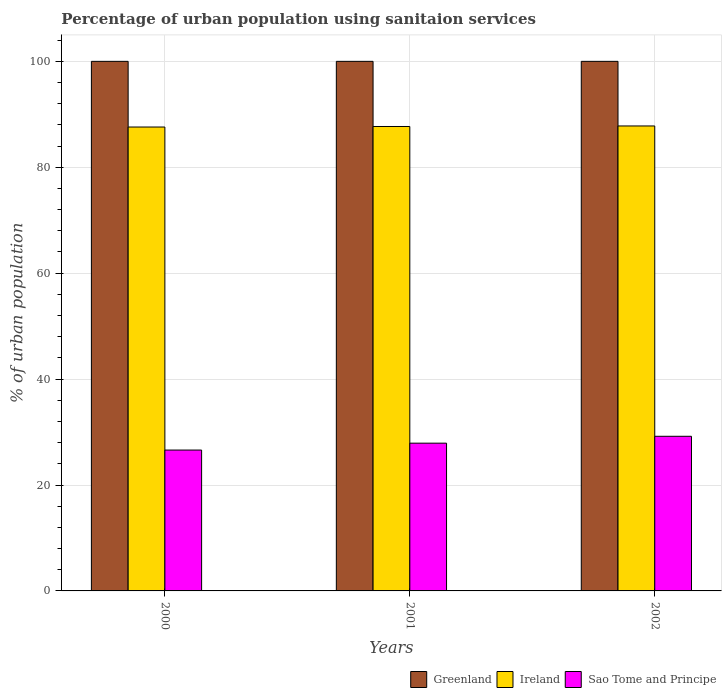How many different coloured bars are there?
Your answer should be very brief. 3. Are the number of bars per tick equal to the number of legend labels?
Your answer should be very brief. Yes. How many bars are there on the 1st tick from the right?
Offer a terse response. 3. What is the label of the 1st group of bars from the left?
Offer a terse response. 2000. In how many cases, is the number of bars for a given year not equal to the number of legend labels?
Provide a succinct answer. 0. What is the percentage of urban population using sanitaion services in Greenland in 2002?
Your answer should be compact. 100. Across all years, what is the maximum percentage of urban population using sanitaion services in Greenland?
Your answer should be very brief. 100. Across all years, what is the minimum percentage of urban population using sanitaion services in Greenland?
Offer a very short reply. 100. In which year was the percentage of urban population using sanitaion services in Greenland minimum?
Ensure brevity in your answer.  2000. What is the total percentage of urban population using sanitaion services in Sao Tome and Principe in the graph?
Provide a short and direct response. 83.7. What is the difference between the percentage of urban population using sanitaion services in Ireland in 2000 and that in 2002?
Your response must be concise. -0.2. What is the difference between the percentage of urban population using sanitaion services in Ireland in 2000 and the percentage of urban population using sanitaion services in Sao Tome and Principe in 2002?
Give a very brief answer. 58.4. In the year 2000, what is the difference between the percentage of urban population using sanitaion services in Greenland and percentage of urban population using sanitaion services in Sao Tome and Principe?
Ensure brevity in your answer.  73.4. In how many years, is the percentage of urban population using sanitaion services in Sao Tome and Principe greater than 12 %?
Give a very brief answer. 3. What is the ratio of the percentage of urban population using sanitaion services in Ireland in 2000 to that in 2001?
Keep it short and to the point. 1. Is the difference between the percentage of urban population using sanitaion services in Greenland in 2001 and 2002 greater than the difference between the percentage of urban population using sanitaion services in Sao Tome and Principe in 2001 and 2002?
Make the answer very short. Yes. What is the difference between the highest and the second highest percentage of urban population using sanitaion services in Greenland?
Offer a terse response. 0. What is the difference between the highest and the lowest percentage of urban population using sanitaion services in Ireland?
Ensure brevity in your answer.  0.2. In how many years, is the percentage of urban population using sanitaion services in Ireland greater than the average percentage of urban population using sanitaion services in Ireland taken over all years?
Offer a terse response. 1. What does the 1st bar from the left in 2000 represents?
Ensure brevity in your answer.  Greenland. What does the 2nd bar from the right in 2002 represents?
Offer a very short reply. Ireland. How many bars are there?
Your answer should be compact. 9. Are the values on the major ticks of Y-axis written in scientific E-notation?
Provide a succinct answer. No. Does the graph contain any zero values?
Offer a very short reply. No. Where does the legend appear in the graph?
Offer a very short reply. Bottom right. What is the title of the graph?
Offer a terse response. Percentage of urban population using sanitaion services. What is the label or title of the X-axis?
Offer a very short reply. Years. What is the label or title of the Y-axis?
Ensure brevity in your answer.  % of urban population. What is the % of urban population of Greenland in 2000?
Your answer should be compact. 100. What is the % of urban population of Ireland in 2000?
Your answer should be very brief. 87.6. What is the % of urban population of Sao Tome and Principe in 2000?
Provide a succinct answer. 26.6. What is the % of urban population of Greenland in 2001?
Your answer should be compact. 100. What is the % of urban population of Ireland in 2001?
Your response must be concise. 87.7. What is the % of urban population of Sao Tome and Principe in 2001?
Your response must be concise. 27.9. What is the % of urban population of Ireland in 2002?
Your response must be concise. 87.8. What is the % of urban population in Sao Tome and Principe in 2002?
Offer a terse response. 29.2. Across all years, what is the maximum % of urban population in Greenland?
Offer a very short reply. 100. Across all years, what is the maximum % of urban population of Ireland?
Give a very brief answer. 87.8. Across all years, what is the maximum % of urban population in Sao Tome and Principe?
Your answer should be compact. 29.2. Across all years, what is the minimum % of urban population of Greenland?
Your answer should be very brief. 100. Across all years, what is the minimum % of urban population in Ireland?
Keep it short and to the point. 87.6. Across all years, what is the minimum % of urban population of Sao Tome and Principe?
Provide a succinct answer. 26.6. What is the total % of urban population in Greenland in the graph?
Provide a succinct answer. 300. What is the total % of urban population of Ireland in the graph?
Your response must be concise. 263.1. What is the total % of urban population in Sao Tome and Principe in the graph?
Make the answer very short. 83.7. What is the difference between the % of urban population of Ireland in 2000 and that in 2002?
Offer a terse response. -0.2. What is the difference between the % of urban population of Sao Tome and Principe in 2000 and that in 2002?
Your response must be concise. -2.6. What is the difference between the % of urban population in Greenland in 2001 and that in 2002?
Offer a terse response. 0. What is the difference between the % of urban population of Ireland in 2001 and that in 2002?
Provide a succinct answer. -0.1. What is the difference between the % of urban population in Greenland in 2000 and the % of urban population in Ireland in 2001?
Your response must be concise. 12.3. What is the difference between the % of urban population in Greenland in 2000 and the % of urban population in Sao Tome and Principe in 2001?
Your answer should be compact. 72.1. What is the difference between the % of urban population of Ireland in 2000 and the % of urban population of Sao Tome and Principe in 2001?
Your answer should be very brief. 59.7. What is the difference between the % of urban population in Greenland in 2000 and the % of urban population in Sao Tome and Principe in 2002?
Your answer should be very brief. 70.8. What is the difference between the % of urban population in Ireland in 2000 and the % of urban population in Sao Tome and Principe in 2002?
Make the answer very short. 58.4. What is the difference between the % of urban population of Greenland in 2001 and the % of urban population of Ireland in 2002?
Offer a terse response. 12.2. What is the difference between the % of urban population of Greenland in 2001 and the % of urban population of Sao Tome and Principe in 2002?
Your response must be concise. 70.8. What is the difference between the % of urban population in Ireland in 2001 and the % of urban population in Sao Tome and Principe in 2002?
Make the answer very short. 58.5. What is the average % of urban population in Ireland per year?
Make the answer very short. 87.7. What is the average % of urban population of Sao Tome and Principe per year?
Make the answer very short. 27.9. In the year 2000, what is the difference between the % of urban population in Greenland and % of urban population in Sao Tome and Principe?
Offer a terse response. 73.4. In the year 2001, what is the difference between the % of urban population of Greenland and % of urban population of Ireland?
Offer a terse response. 12.3. In the year 2001, what is the difference between the % of urban population of Greenland and % of urban population of Sao Tome and Principe?
Your answer should be very brief. 72.1. In the year 2001, what is the difference between the % of urban population in Ireland and % of urban population in Sao Tome and Principe?
Make the answer very short. 59.8. In the year 2002, what is the difference between the % of urban population in Greenland and % of urban population in Ireland?
Your answer should be very brief. 12.2. In the year 2002, what is the difference between the % of urban population of Greenland and % of urban population of Sao Tome and Principe?
Offer a very short reply. 70.8. In the year 2002, what is the difference between the % of urban population of Ireland and % of urban population of Sao Tome and Principe?
Ensure brevity in your answer.  58.6. What is the ratio of the % of urban population of Greenland in 2000 to that in 2001?
Your response must be concise. 1. What is the ratio of the % of urban population in Ireland in 2000 to that in 2001?
Keep it short and to the point. 1. What is the ratio of the % of urban population of Sao Tome and Principe in 2000 to that in 2001?
Give a very brief answer. 0.95. What is the ratio of the % of urban population of Sao Tome and Principe in 2000 to that in 2002?
Offer a very short reply. 0.91. What is the ratio of the % of urban population in Greenland in 2001 to that in 2002?
Your answer should be compact. 1. What is the ratio of the % of urban population in Sao Tome and Principe in 2001 to that in 2002?
Keep it short and to the point. 0.96. What is the difference between the highest and the second highest % of urban population in Sao Tome and Principe?
Make the answer very short. 1.3. What is the difference between the highest and the lowest % of urban population of Ireland?
Make the answer very short. 0.2. What is the difference between the highest and the lowest % of urban population in Sao Tome and Principe?
Keep it short and to the point. 2.6. 